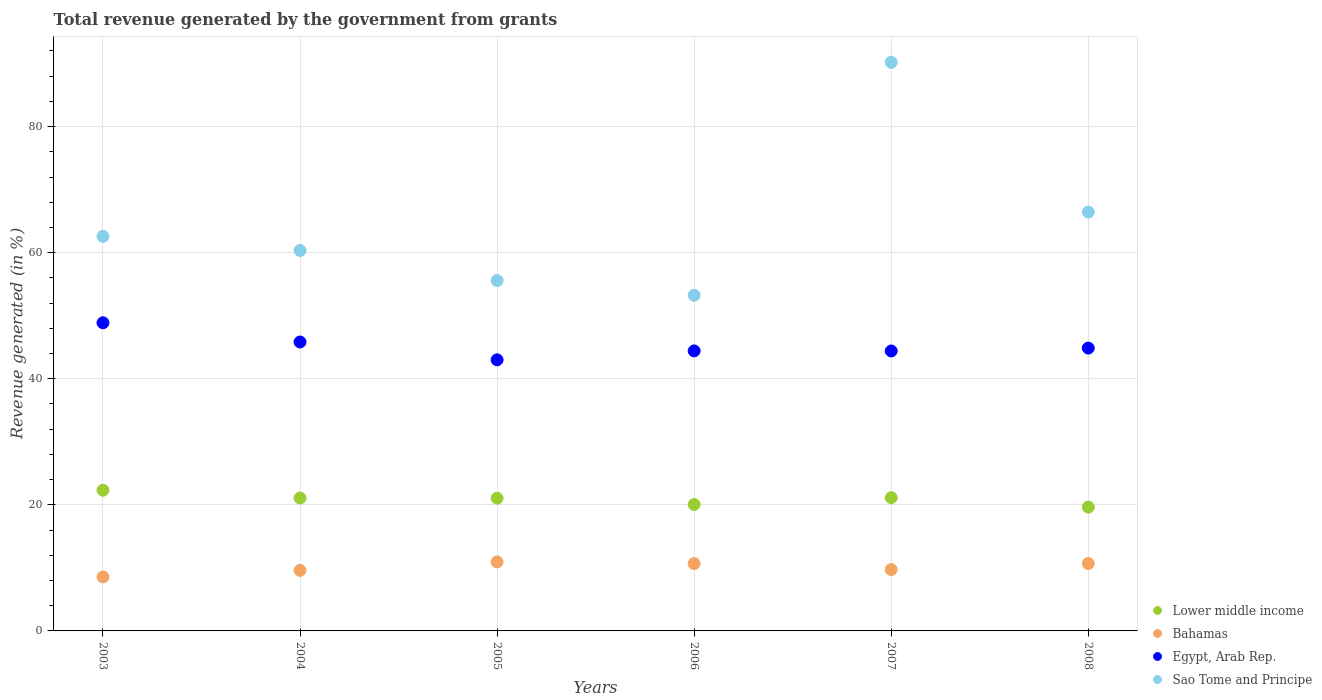What is the total revenue generated in Bahamas in 2005?
Your answer should be compact. 10.95. Across all years, what is the maximum total revenue generated in Sao Tome and Principe?
Provide a short and direct response. 90.2. Across all years, what is the minimum total revenue generated in Egypt, Arab Rep.?
Keep it short and to the point. 43.01. What is the total total revenue generated in Bahamas in the graph?
Offer a terse response. 60.23. What is the difference between the total revenue generated in Bahamas in 2007 and that in 2008?
Your answer should be compact. -0.97. What is the difference between the total revenue generated in Egypt, Arab Rep. in 2005 and the total revenue generated in Sao Tome and Principe in 2007?
Make the answer very short. -47.2. What is the average total revenue generated in Lower middle income per year?
Offer a terse response. 20.88. In the year 2006, what is the difference between the total revenue generated in Egypt, Arab Rep. and total revenue generated in Lower middle income?
Ensure brevity in your answer.  24.38. What is the ratio of the total revenue generated in Egypt, Arab Rep. in 2006 to that in 2007?
Keep it short and to the point. 1. Is the total revenue generated in Sao Tome and Principe in 2005 less than that in 2007?
Your answer should be compact. Yes. Is the difference between the total revenue generated in Egypt, Arab Rep. in 2003 and 2004 greater than the difference between the total revenue generated in Lower middle income in 2003 and 2004?
Your answer should be very brief. Yes. What is the difference between the highest and the second highest total revenue generated in Sao Tome and Principe?
Ensure brevity in your answer.  23.75. What is the difference between the highest and the lowest total revenue generated in Sao Tome and Principe?
Offer a very short reply. 36.96. In how many years, is the total revenue generated in Sao Tome and Principe greater than the average total revenue generated in Sao Tome and Principe taken over all years?
Your response must be concise. 2. Is the sum of the total revenue generated in Lower middle income in 2004 and 2006 greater than the maximum total revenue generated in Egypt, Arab Rep. across all years?
Give a very brief answer. No. Is it the case that in every year, the sum of the total revenue generated in Sao Tome and Principe and total revenue generated in Lower middle income  is greater than the sum of total revenue generated in Egypt, Arab Rep. and total revenue generated in Bahamas?
Offer a terse response. Yes. Is it the case that in every year, the sum of the total revenue generated in Egypt, Arab Rep. and total revenue generated in Lower middle income  is greater than the total revenue generated in Bahamas?
Your answer should be compact. Yes. Does the total revenue generated in Sao Tome and Principe monotonically increase over the years?
Your answer should be very brief. No. Is the total revenue generated in Lower middle income strictly greater than the total revenue generated in Egypt, Arab Rep. over the years?
Keep it short and to the point. No. Are the values on the major ticks of Y-axis written in scientific E-notation?
Your answer should be compact. No. Does the graph contain any zero values?
Keep it short and to the point. No. Does the graph contain grids?
Keep it short and to the point. Yes. How are the legend labels stacked?
Provide a short and direct response. Vertical. What is the title of the graph?
Make the answer very short. Total revenue generated by the government from grants. Does "Panama" appear as one of the legend labels in the graph?
Provide a short and direct response. No. What is the label or title of the Y-axis?
Offer a very short reply. Revenue generated (in %). What is the Revenue generated (in %) of Lower middle income in 2003?
Provide a short and direct response. 22.32. What is the Revenue generated (in %) of Bahamas in 2003?
Your response must be concise. 8.57. What is the Revenue generated (in %) of Egypt, Arab Rep. in 2003?
Offer a terse response. 48.88. What is the Revenue generated (in %) of Sao Tome and Principe in 2003?
Ensure brevity in your answer.  62.58. What is the Revenue generated (in %) in Lower middle income in 2004?
Ensure brevity in your answer.  21.08. What is the Revenue generated (in %) in Bahamas in 2004?
Your answer should be compact. 9.6. What is the Revenue generated (in %) of Egypt, Arab Rep. in 2004?
Keep it short and to the point. 45.83. What is the Revenue generated (in %) in Sao Tome and Principe in 2004?
Ensure brevity in your answer.  60.35. What is the Revenue generated (in %) in Lower middle income in 2005?
Keep it short and to the point. 21.06. What is the Revenue generated (in %) in Bahamas in 2005?
Offer a very short reply. 10.95. What is the Revenue generated (in %) in Egypt, Arab Rep. in 2005?
Make the answer very short. 43.01. What is the Revenue generated (in %) in Sao Tome and Principe in 2005?
Offer a very short reply. 55.58. What is the Revenue generated (in %) of Lower middle income in 2006?
Ensure brevity in your answer.  20.05. What is the Revenue generated (in %) in Bahamas in 2006?
Provide a short and direct response. 10.69. What is the Revenue generated (in %) of Egypt, Arab Rep. in 2006?
Ensure brevity in your answer.  44.42. What is the Revenue generated (in %) of Sao Tome and Principe in 2006?
Provide a short and direct response. 53.24. What is the Revenue generated (in %) in Lower middle income in 2007?
Provide a succinct answer. 21.14. What is the Revenue generated (in %) in Bahamas in 2007?
Offer a terse response. 9.73. What is the Revenue generated (in %) of Egypt, Arab Rep. in 2007?
Make the answer very short. 44.41. What is the Revenue generated (in %) of Sao Tome and Principe in 2007?
Give a very brief answer. 90.2. What is the Revenue generated (in %) of Lower middle income in 2008?
Give a very brief answer. 19.64. What is the Revenue generated (in %) in Bahamas in 2008?
Offer a terse response. 10.7. What is the Revenue generated (in %) in Egypt, Arab Rep. in 2008?
Give a very brief answer. 44.87. What is the Revenue generated (in %) of Sao Tome and Principe in 2008?
Give a very brief answer. 66.45. Across all years, what is the maximum Revenue generated (in %) of Lower middle income?
Ensure brevity in your answer.  22.32. Across all years, what is the maximum Revenue generated (in %) in Bahamas?
Provide a short and direct response. 10.95. Across all years, what is the maximum Revenue generated (in %) of Egypt, Arab Rep.?
Provide a succinct answer. 48.88. Across all years, what is the maximum Revenue generated (in %) of Sao Tome and Principe?
Make the answer very short. 90.2. Across all years, what is the minimum Revenue generated (in %) in Lower middle income?
Keep it short and to the point. 19.64. Across all years, what is the minimum Revenue generated (in %) in Bahamas?
Your answer should be compact. 8.57. Across all years, what is the minimum Revenue generated (in %) in Egypt, Arab Rep.?
Offer a very short reply. 43.01. Across all years, what is the minimum Revenue generated (in %) in Sao Tome and Principe?
Keep it short and to the point. 53.24. What is the total Revenue generated (in %) of Lower middle income in the graph?
Your answer should be compact. 125.28. What is the total Revenue generated (in %) of Bahamas in the graph?
Provide a short and direct response. 60.23. What is the total Revenue generated (in %) in Egypt, Arab Rep. in the graph?
Your answer should be very brief. 271.42. What is the total Revenue generated (in %) of Sao Tome and Principe in the graph?
Your response must be concise. 388.4. What is the difference between the Revenue generated (in %) in Lower middle income in 2003 and that in 2004?
Ensure brevity in your answer.  1.24. What is the difference between the Revenue generated (in %) in Bahamas in 2003 and that in 2004?
Provide a short and direct response. -1.04. What is the difference between the Revenue generated (in %) in Egypt, Arab Rep. in 2003 and that in 2004?
Give a very brief answer. 3.05. What is the difference between the Revenue generated (in %) in Sao Tome and Principe in 2003 and that in 2004?
Offer a terse response. 2.24. What is the difference between the Revenue generated (in %) in Lower middle income in 2003 and that in 2005?
Provide a short and direct response. 1.26. What is the difference between the Revenue generated (in %) of Bahamas in 2003 and that in 2005?
Your answer should be compact. -2.38. What is the difference between the Revenue generated (in %) in Egypt, Arab Rep. in 2003 and that in 2005?
Offer a very short reply. 5.88. What is the difference between the Revenue generated (in %) of Sao Tome and Principe in 2003 and that in 2005?
Your answer should be compact. 7. What is the difference between the Revenue generated (in %) in Lower middle income in 2003 and that in 2006?
Offer a very short reply. 2.27. What is the difference between the Revenue generated (in %) of Bahamas in 2003 and that in 2006?
Give a very brief answer. -2.12. What is the difference between the Revenue generated (in %) in Egypt, Arab Rep. in 2003 and that in 2006?
Provide a short and direct response. 4.46. What is the difference between the Revenue generated (in %) in Sao Tome and Principe in 2003 and that in 2006?
Keep it short and to the point. 9.35. What is the difference between the Revenue generated (in %) of Lower middle income in 2003 and that in 2007?
Keep it short and to the point. 1.18. What is the difference between the Revenue generated (in %) of Bahamas in 2003 and that in 2007?
Provide a succinct answer. -1.16. What is the difference between the Revenue generated (in %) in Egypt, Arab Rep. in 2003 and that in 2007?
Make the answer very short. 4.47. What is the difference between the Revenue generated (in %) in Sao Tome and Principe in 2003 and that in 2007?
Provide a succinct answer. -27.62. What is the difference between the Revenue generated (in %) of Lower middle income in 2003 and that in 2008?
Your answer should be very brief. 2.68. What is the difference between the Revenue generated (in %) of Bahamas in 2003 and that in 2008?
Offer a terse response. -2.13. What is the difference between the Revenue generated (in %) in Egypt, Arab Rep. in 2003 and that in 2008?
Your answer should be compact. 4.02. What is the difference between the Revenue generated (in %) of Sao Tome and Principe in 2003 and that in 2008?
Offer a very short reply. -3.86. What is the difference between the Revenue generated (in %) in Lower middle income in 2004 and that in 2005?
Your answer should be very brief. 0.02. What is the difference between the Revenue generated (in %) of Bahamas in 2004 and that in 2005?
Offer a very short reply. -1.35. What is the difference between the Revenue generated (in %) in Egypt, Arab Rep. in 2004 and that in 2005?
Your answer should be very brief. 2.83. What is the difference between the Revenue generated (in %) in Sao Tome and Principe in 2004 and that in 2005?
Provide a short and direct response. 4.76. What is the difference between the Revenue generated (in %) of Lower middle income in 2004 and that in 2006?
Your response must be concise. 1.03. What is the difference between the Revenue generated (in %) in Bahamas in 2004 and that in 2006?
Your answer should be compact. -1.08. What is the difference between the Revenue generated (in %) of Egypt, Arab Rep. in 2004 and that in 2006?
Offer a very short reply. 1.41. What is the difference between the Revenue generated (in %) in Sao Tome and Principe in 2004 and that in 2006?
Offer a very short reply. 7.11. What is the difference between the Revenue generated (in %) in Lower middle income in 2004 and that in 2007?
Offer a very short reply. -0.06. What is the difference between the Revenue generated (in %) in Bahamas in 2004 and that in 2007?
Your answer should be very brief. -0.13. What is the difference between the Revenue generated (in %) in Egypt, Arab Rep. in 2004 and that in 2007?
Offer a very short reply. 1.43. What is the difference between the Revenue generated (in %) of Sao Tome and Principe in 2004 and that in 2007?
Give a very brief answer. -29.85. What is the difference between the Revenue generated (in %) in Lower middle income in 2004 and that in 2008?
Keep it short and to the point. 1.44. What is the difference between the Revenue generated (in %) in Bahamas in 2004 and that in 2008?
Offer a terse response. -1.09. What is the difference between the Revenue generated (in %) in Egypt, Arab Rep. in 2004 and that in 2008?
Offer a very short reply. 0.97. What is the difference between the Revenue generated (in %) of Sao Tome and Principe in 2004 and that in 2008?
Provide a succinct answer. -6.1. What is the difference between the Revenue generated (in %) in Lower middle income in 2005 and that in 2006?
Provide a short and direct response. 1.01. What is the difference between the Revenue generated (in %) in Bahamas in 2005 and that in 2006?
Your answer should be very brief. 0.26. What is the difference between the Revenue generated (in %) of Egypt, Arab Rep. in 2005 and that in 2006?
Provide a short and direct response. -1.42. What is the difference between the Revenue generated (in %) in Sao Tome and Principe in 2005 and that in 2006?
Offer a very short reply. 2.35. What is the difference between the Revenue generated (in %) of Lower middle income in 2005 and that in 2007?
Your answer should be very brief. -0.08. What is the difference between the Revenue generated (in %) in Bahamas in 2005 and that in 2007?
Ensure brevity in your answer.  1.22. What is the difference between the Revenue generated (in %) of Egypt, Arab Rep. in 2005 and that in 2007?
Offer a terse response. -1.4. What is the difference between the Revenue generated (in %) in Sao Tome and Principe in 2005 and that in 2007?
Make the answer very short. -34.62. What is the difference between the Revenue generated (in %) of Lower middle income in 2005 and that in 2008?
Your answer should be compact. 1.42. What is the difference between the Revenue generated (in %) in Bahamas in 2005 and that in 2008?
Give a very brief answer. 0.25. What is the difference between the Revenue generated (in %) of Egypt, Arab Rep. in 2005 and that in 2008?
Ensure brevity in your answer.  -1.86. What is the difference between the Revenue generated (in %) of Sao Tome and Principe in 2005 and that in 2008?
Make the answer very short. -10.86. What is the difference between the Revenue generated (in %) in Lower middle income in 2006 and that in 2007?
Provide a short and direct response. -1.09. What is the difference between the Revenue generated (in %) in Bahamas in 2006 and that in 2007?
Offer a terse response. 0.96. What is the difference between the Revenue generated (in %) in Egypt, Arab Rep. in 2006 and that in 2007?
Your answer should be very brief. 0.01. What is the difference between the Revenue generated (in %) of Sao Tome and Principe in 2006 and that in 2007?
Give a very brief answer. -36.96. What is the difference between the Revenue generated (in %) in Lower middle income in 2006 and that in 2008?
Give a very brief answer. 0.4. What is the difference between the Revenue generated (in %) of Bahamas in 2006 and that in 2008?
Offer a very short reply. -0.01. What is the difference between the Revenue generated (in %) of Egypt, Arab Rep. in 2006 and that in 2008?
Keep it short and to the point. -0.44. What is the difference between the Revenue generated (in %) of Sao Tome and Principe in 2006 and that in 2008?
Your answer should be very brief. -13.21. What is the difference between the Revenue generated (in %) of Lower middle income in 2007 and that in 2008?
Offer a very short reply. 1.5. What is the difference between the Revenue generated (in %) in Bahamas in 2007 and that in 2008?
Provide a succinct answer. -0.97. What is the difference between the Revenue generated (in %) in Egypt, Arab Rep. in 2007 and that in 2008?
Your answer should be very brief. -0.46. What is the difference between the Revenue generated (in %) in Sao Tome and Principe in 2007 and that in 2008?
Provide a short and direct response. 23.75. What is the difference between the Revenue generated (in %) of Lower middle income in 2003 and the Revenue generated (in %) of Bahamas in 2004?
Your answer should be compact. 12.72. What is the difference between the Revenue generated (in %) of Lower middle income in 2003 and the Revenue generated (in %) of Egypt, Arab Rep. in 2004?
Provide a succinct answer. -23.51. What is the difference between the Revenue generated (in %) in Lower middle income in 2003 and the Revenue generated (in %) in Sao Tome and Principe in 2004?
Provide a succinct answer. -38.03. What is the difference between the Revenue generated (in %) of Bahamas in 2003 and the Revenue generated (in %) of Egypt, Arab Rep. in 2004?
Ensure brevity in your answer.  -37.27. What is the difference between the Revenue generated (in %) of Bahamas in 2003 and the Revenue generated (in %) of Sao Tome and Principe in 2004?
Keep it short and to the point. -51.78. What is the difference between the Revenue generated (in %) of Egypt, Arab Rep. in 2003 and the Revenue generated (in %) of Sao Tome and Principe in 2004?
Offer a terse response. -11.46. What is the difference between the Revenue generated (in %) in Lower middle income in 2003 and the Revenue generated (in %) in Bahamas in 2005?
Your answer should be very brief. 11.37. What is the difference between the Revenue generated (in %) in Lower middle income in 2003 and the Revenue generated (in %) in Egypt, Arab Rep. in 2005?
Your answer should be very brief. -20.69. What is the difference between the Revenue generated (in %) of Lower middle income in 2003 and the Revenue generated (in %) of Sao Tome and Principe in 2005?
Ensure brevity in your answer.  -33.26. What is the difference between the Revenue generated (in %) of Bahamas in 2003 and the Revenue generated (in %) of Egypt, Arab Rep. in 2005?
Provide a succinct answer. -34.44. What is the difference between the Revenue generated (in %) in Bahamas in 2003 and the Revenue generated (in %) in Sao Tome and Principe in 2005?
Provide a succinct answer. -47.02. What is the difference between the Revenue generated (in %) in Egypt, Arab Rep. in 2003 and the Revenue generated (in %) in Sao Tome and Principe in 2005?
Give a very brief answer. -6.7. What is the difference between the Revenue generated (in %) of Lower middle income in 2003 and the Revenue generated (in %) of Bahamas in 2006?
Offer a terse response. 11.63. What is the difference between the Revenue generated (in %) in Lower middle income in 2003 and the Revenue generated (in %) in Egypt, Arab Rep. in 2006?
Your answer should be compact. -22.1. What is the difference between the Revenue generated (in %) of Lower middle income in 2003 and the Revenue generated (in %) of Sao Tome and Principe in 2006?
Your response must be concise. -30.92. What is the difference between the Revenue generated (in %) of Bahamas in 2003 and the Revenue generated (in %) of Egypt, Arab Rep. in 2006?
Provide a short and direct response. -35.85. What is the difference between the Revenue generated (in %) of Bahamas in 2003 and the Revenue generated (in %) of Sao Tome and Principe in 2006?
Your response must be concise. -44.67. What is the difference between the Revenue generated (in %) of Egypt, Arab Rep. in 2003 and the Revenue generated (in %) of Sao Tome and Principe in 2006?
Provide a succinct answer. -4.36. What is the difference between the Revenue generated (in %) in Lower middle income in 2003 and the Revenue generated (in %) in Bahamas in 2007?
Ensure brevity in your answer.  12.59. What is the difference between the Revenue generated (in %) in Lower middle income in 2003 and the Revenue generated (in %) in Egypt, Arab Rep. in 2007?
Your answer should be compact. -22.09. What is the difference between the Revenue generated (in %) of Lower middle income in 2003 and the Revenue generated (in %) of Sao Tome and Principe in 2007?
Keep it short and to the point. -67.88. What is the difference between the Revenue generated (in %) of Bahamas in 2003 and the Revenue generated (in %) of Egypt, Arab Rep. in 2007?
Give a very brief answer. -35.84. What is the difference between the Revenue generated (in %) of Bahamas in 2003 and the Revenue generated (in %) of Sao Tome and Principe in 2007?
Your answer should be very brief. -81.63. What is the difference between the Revenue generated (in %) in Egypt, Arab Rep. in 2003 and the Revenue generated (in %) in Sao Tome and Principe in 2007?
Offer a very short reply. -41.32. What is the difference between the Revenue generated (in %) of Lower middle income in 2003 and the Revenue generated (in %) of Bahamas in 2008?
Your answer should be very brief. 11.62. What is the difference between the Revenue generated (in %) in Lower middle income in 2003 and the Revenue generated (in %) in Egypt, Arab Rep. in 2008?
Make the answer very short. -22.55. What is the difference between the Revenue generated (in %) in Lower middle income in 2003 and the Revenue generated (in %) in Sao Tome and Principe in 2008?
Keep it short and to the point. -44.13. What is the difference between the Revenue generated (in %) of Bahamas in 2003 and the Revenue generated (in %) of Egypt, Arab Rep. in 2008?
Your answer should be compact. -36.3. What is the difference between the Revenue generated (in %) of Bahamas in 2003 and the Revenue generated (in %) of Sao Tome and Principe in 2008?
Make the answer very short. -57.88. What is the difference between the Revenue generated (in %) of Egypt, Arab Rep. in 2003 and the Revenue generated (in %) of Sao Tome and Principe in 2008?
Provide a short and direct response. -17.56. What is the difference between the Revenue generated (in %) in Lower middle income in 2004 and the Revenue generated (in %) in Bahamas in 2005?
Your answer should be very brief. 10.13. What is the difference between the Revenue generated (in %) in Lower middle income in 2004 and the Revenue generated (in %) in Egypt, Arab Rep. in 2005?
Provide a short and direct response. -21.93. What is the difference between the Revenue generated (in %) of Lower middle income in 2004 and the Revenue generated (in %) of Sao Tome and Principe in 2005?
Your answer should be compact. -34.51. What is the difference between the Revenue generated (in %) in Bahamas in 2004 and the Revenue generated (in %) in Egypt, Arab Rep. in 2005?
Keep it short and to the point. -33.4. What is the difference between the Revenue generated (in %) in Bahamas in 2004 and the Revenue generated (in %) in Sao Tome and Principe in 2005?
Keep it short and to the point. -45.98. What is the difference between the Revenue generated (in %) in Egypt, Arab Rep. in 2004 and the Revenue generated (in %) in Sao Tome and Principe in 2005?
Your answer should be compact. -9.75. What is the difference between the Revenue generated (in %) in Lower middle income in 2004 and the Revenue generated (in %) in Bahamas in 2006?
Offer a terse response. 10.39. What is the difference between the Revenue generated (in %) in Lower middle income in 2004 and the Revenue generated (in %) in Egypt, Arab Rep. in 2006?
Keep it short and to the point. -23.34. What is the difference between the Revenue generated (in %) in Lower middle income in 2004 and the Revenue generated (in %) in Sao Tome and Principe in 2006?
Your response must be concise. -32.16. What is the difference between the Revenue generated (in %) in Bahamas in 2004 and the Revenue generated (in %) in Egypt, Arab Rep. in 2006?
Give a very brief answer. -34.82. What is the difference between the Revenue generated (in %) in Bahamas in 2004 and the Revenue generated (in %) in Sao Tome and Principe in 2006?
Give a very brief answer. -43.63. What is the difference between the Revenue generated (in %) in Egypt, Arab Rep. in 2004 and the Revenue generated (in %) in Sao Tome and Principe in 2006?
Keep it short and to the point. -7.4. What is the difference between the Revenue generated (in %) in Lower middle income in 2004 and the Revenue generated (in %) in Bahamas in 2007?
Offer a very short reply. 11.35. What is the difference between the Revenue generated (in %) of Lower middle income in 2004 and the Revenue generated (in %) of Egypt, Arab Rep. in 2007?
Your response must be concise. -23.33. What is the difference between the Revenue generated (in %) of Lower middle income in 2004 and the Revenue generated (in %) of Sao Tome and Principe in 2007?
Your response must be concise. -69.12. What is the difference between the Revenue generated (in %) in Bahamas in 2004 and the Revenue generated (in %) in Egypt, Arab Rep. in 2007?
Your answer should be compact. -34.81. What is the difference between the Revenue generated (in %) of Bahamas in 2004 and the Revenue generated (in %) of Sao Tome and Principe in 2007?
Your answer should be compact. -80.6. What is the difference between the Revenue generated (in %) of Egypt, Arab Rep. in 2004 and the Revenue generated (in %) of Sao Tome and Principe in 2007?
Make the answer very short. -44.37. What is the difference between the Revenue generated (in %) in Lower middle income in 2004 and the Revenue generated (in %) in Bahamas in 2008?
Provide a short and direct response. 10.38. What is the difference between the Revenue generated (in %) in Lower middle income in 2004 and the Revenue generated (in %) in Egypt, Arab Rep. in 2008?
Make the answer very short. -23.79. What is the difference between the Revenue generated (in %) of Lower middle income in 2004 and the Revenue generated (in %) of Sao Tome and Principe in 2008?
Your response must be concise. -45.37. What is the difference between the Revenue generated (in %) of Bahamas in 2004 and the Revenue generated (in %) of Egypt, Arab Rep. in 2008?
Make the answer very short. -35.26. What is the difference between the Revenue generated (in %) of Bahamas in 2004 and the Revenue generated (in %) of Sao Tome and Principe in 2008?
Offer a terse response. -56.84. What is the difference between the Revenue generated (in %) of Egypt, Arab Rep. in 2004 and the Revenue generated (in %) of Sao Tome and Principe in 2008?
Make the answer very short. -20.61. What is the difference between the Revenue generated (in %) in Lower middle income in 2005 and the Revenue generated (in %) in Bahamas in 2006?
Provide a succinct answer. 10.37. What is the difference between the Revenue generated (in %) in Lower middle income in 2005 and the Revenue generated (in %) in Egypt, Arab Rep. in 2006?
Give a very brief answer. -23.36. What is the difference between the Revenue generated (in %) of Lower middle income in 2005 and the Revenue generated (in %) of Sao Tome and Principe in 2006?
Make the answer very short. -32.18. What is the difference between the Revenue generated (in %) in Bahamas in 2005 and the Revenue generated (in %) in Egypt, Arab Rep. in 2006?
Your answer should be very brief. -33.47. What is the difference between the Revenue generated (in %) in Bahamas in 2005 and the Revenue generated (in %) in Sao Tome and Principe in 2006?
Give a very brief answer. -42.29. What is the difference between the Revenue generated (in %) in Egypt, Arab Rep. in 2005 and the Revenue generated (in %) in Sao Tome and Principe in 2006?
Make the answer very short. -10.23. What is the difference between the Revenue generated (in %) in Lower middle income in 2005 and the Revenue generated (in %) in Bahamas in 2007?
Your response must be concise. 11.33. What is the difference between the Revenue generated (in %) in Lower middle income in 2005 and the Revenue generated (in %) in Egypt, Arab Rep. in 2007?
Your answer should be compact. -23.35. What is the difference between the Revenue generated (in %) in Lower middle income in 2005 and the Revenue generated (in %) in Sao Tome and Principe in 2007?
Offer a terse response. -69.14. What is the difference between the Revenue generated (in %) of Bahamas in 2005 and the Revenue generated (in %) of Egypt, Arab Rep. in 2007?
Ensure brevity in your answer.  -33.46. What is the difference between the Revenue generated (in %) of Bahamas in 2005 and the Revenue generated (in %) of Sao Tome and Principe in 2007?
Offer a very short reply. -79.25. What is the difference between the Revenue generated (in %) of Egypt, Arab Rep. in 2005 and the Revenue generated (in %) of Sao Tome and Principe in 2007?
Make the answer very short. -47.2. What is the difference between the Revenue generated (in %) of Lower middle income in 2005 and the Revenue generated (in %) of Bahamas in 2008?
Offer a very short reply. 10.36. What is the difference between the Revenue generated (in %) in Lower middle income in 2005 and the Revenue generated (in %) in Egypt, Arab Rep. in 2008?
Provide a short and direct response. -23.81. What is the difference between the Revenue generated (in %) in Lower middle income in 2005 and the Revenue generated (in %) in Sao Tome and Principe in 2008?
Provide a short and direct response. -45.39. What is the difference between the Revenue generated (in %) in Bahamas in 2005 and the Revenue generated (in %) in Egypt, Arab Rep. in 2008?
Offer a terse response. -33.91. What is the difference between the Revenue generated (in %) in Bahamas in 2005 and the Revenue generated (in %) in Sao Tome and Principe in 2008?
Provide a short and direct response. -55.5. What is the difference between the Revenue generated (in %) of Egypt, Arab Rep. in 2005 and the Revenue generated (in %) of Sao Tome and Principe in 2008?
Your response must be concise. -23.44. What is the difference between the Revenue generated (in %) of Lower middle income in 2006 and the Revenue generated (in %) of Bahamas in 2007?
Your response must be concise. 10.32. What is the difference between the Revenue generated (in %) in Lower middle income in 2006 and the Revenue generated (in %) in Egypt, Arab Rep. in 2007?
Offer a very short reply. -24.36. What is the difference between the Revenue generated (in %) in Lower middle income in 2006 and the Revenue generated (in %) in Sao Tome and Principe in 2007?
Your answer should be very brief. -70.15. What is the difference between the Revenue generated (in %) of Bahamas in 2006 and the Revenue generated (in %) of Egypt, Arab Rep. in 2007?
Ensure brevity in your answer.  -33.72. What is the difference between the Revenue generated (in %) in Bahamas in 2006 and the Revenue generated (in %) in Sao Tome and Principe in 2007?
Provide a short and direct response. -79.51. What is the difference between the Revenue generated (in %) in Egypt, Arab Rep. in 2006 and the Revenue generated (in %) in Sao Tome and Principe in 2007?
Your response must be concise. -45.78. What is the difference between the Revenue generated (in %) of Lower middle income in 2006 and the Revenue generated (in %) of Bahamas in 2008?
Your answer should be compact. 9.35. What is the difference between the Revenue generated (in %) in Lower middle income in 2006 and the Revenue generated (in %) in Egypt, Arab Rep. in 2008?
Offer a very short reply. -24.82. What is the difference between the Revenue generated (in %) of Lower middle income in 2006 and the Revenue generated (in %) of Sao Tome and Principe in 2008?
Make the answer very short. -46.4. What is the difference between the Revenue generated (in %) in Bahamas in 2006 and the Revenue generated (in %) in Egypt, Arab Rep. in 2008?
Give a very brief answer. -34.18. What is the difference between the Revenue generated (in %) in Bahamas in 2006 and the Revenue generated (in %) in Sao Tome and Principe in 2008?
Provide a succinct answer. -55.76. What is the difference between the Revenue generated (in %) of Egypt, Arab Rep. in 2006 and the Revenue generated (in %) of Sao Tome and Principe in 2008?
Your answer should be compact. -22.02. What is the difference between the Revenue generated (in %) of Lower middle income in 2007 and the Revenue generated (in %) of Bahamas in 2008?
Keep it short and to the point. 10.44. What is the difference between the Revenue generated (in %) of Lower middle income in 2007 and the Revenue generated (in %) of Egypt, Arab Rep. in 2008?
Offer a very short reply. -23.73. What is the difference between the Revenue generated (in %) in Lower middle income in 2007 and the Revenue generated (in %) in Sao Tome and Principe in 2008?
Your response must be concise. -45.31. What is the difference between the Revenue generated (in %) of Bahamas in 2007 and the Revenue generated (in %) of Egypt, Arab Rep. in 2008?
Provide a succinct answer. -35.14. What is the difference between the Revenue generated (in %) in Bahamas in 2007 and the Revenue generated (in %) in Sao Tome and Principe in 2008?
Keep it short and to the point. -56.72. What is the difference between the Revenue generated (in %) of Egypt, Arab Rep. in 2007 and the Revenue generated (in %) of Sao Tome and Principe in 2008?
Offer a terse response. -22.04. What is the average Revenue generated (in %) of Lower middle income per year?
Your answer should be compact. 20.88. What is the average Revenue generated (in %) of Bahamas per year?
Offer a very short reply. 10.04. What is the average Revenue generated (in %) of Egypt, Arab Rep. per year?
Keep it short and to the point. 45.24. What is the average Revenue generated (in %) of Sao Tome and Principe per year?
Provide a succinct answer. 64.73. In the year 2003, what is the difference between the Revenue generated (in %) in Lower middle income and Revenue generated (in %) in Bahamas?
Ensure brevity in your answer.  13.75. In the year 2003, what is the difference between the Revenue generated (in %) in Lower middle income and Revenue generated (in %) in Egypt, Arab Rep.?
Offer a very short reply. -26.56. In the year 2003, what is the difference between the Revenue generated (in %) in Lower middle income and Revenue generated (in %) in Sao Tome and Principe?
Ensure brevity in your answer.  -40.27. In the year 2003, what is the difference between the Revenue generated (in %) of Bahamas and Revenue generated (in %) of Egypt, Arab Rep.?
Your answer should be very brief. -40.31. In the year 2003, what is the difference between the Revenue generated (in %) of Bahamas and Revenue generated (in %) of Sao Tome and Principe?
Your answer should be compact. -54.02. In the year 2003, what is the difference between the Revenue generated (in %) in Egypt, Arab Rep. and Revenue generated (in %) in Sao Tome and Principe?
Your response must be concise. -13.7. In the year 2004, what is the difference between the Revenue generated (in %) of Lower middle income and Revenue generated (in %) of Bahamas?
Provide a succinct answer. 11.47. In the year 2004, what is the difference between the Revenue generated (in %) of Lower middle income and Revenue generated (in %) of Egypt, Arab Rep.?
Offer a very short reply. -24.76. In the year 2004, what is the difference between the Revenue generated (in %) of Lower middle income and Revenue generated (in %) of Sao Tome and Principe?
Offer a very short reply. -39.27. In the year 2004, what is the difference between the Revenue generated (in %) in Bahamas and Revenue generated (in %) in Egypt, Arab Rep.?
Keep it short and to the point. -36.23. In the year 2004, what is the difference between the Revenue generated (in %) in Bahamas and Revenue generated (in %) in Sao Tome and Principe?
Your response must be concise. -50.74. In the year 2004, what is the difference between the Revenue generated (in %) in Egypt, Arab Rep. and Revenue generated (in %) in Sao Tome and Principe?
Provide a short and direct response. -14.51. In the year 2005, what is the difference between the Revenue generated (in %) in Lower middle income and Revenue generated (in %) in Bahamas?
Give a very brief answer. 10.11. In the year 2005, what is the difference between the Revenue generated (in %) in Lower middle income and Revenue generated (in %) in Egypt, Arab Rep.?
Offer a very short reply. -21.95. In the year 2005, what is the difference between the Revenue generated (in %) of Lower middle income and Revenue generated (in %) of Sao Tome and Principe?
Offer a very short reply. -34.52. In the year 2005, what is the difference between the Revenue generated (in %) in Bahamas and Revenue generated (in %) in Egypt, Arab Rep.?
Your response must be concise. -32.05. In the year 2005, what is the difference between the Revenue generated (in %) of Bahamas and Revenue generated (in %) of Sao Tome and Principe?
Offer a very short reply. -44.63. In the year 2005, what is the difference between the Revenue generated (in %) of Egypt, Arab Rep. and Revenue generated (in %) of Sao Tome and Principe?
Ensure brevity in your answer.  -12.58. In the year 2006, what is the difference between the Revenue generated (in %) of Lower middle income and Revenue generated (in %) of Bahamas?
Make the answer very short. 9.36. In the year 2006, what is the difference between the Revenue generated (in %) of Lower middle income and Revenue generated (in %) of Egypt, Arab Rep.?
Your answer should be very brief. -24.38. In the year 2006, what is the difference between the Revenue generated (in %) of Lower middle income and Revenue generated (in %) of Sao Tome and Principe?
Provide a succinct answer. -33.19. In the year 2006, what is the difference between the Revenue generated (in %) in Bahamas and Revenue generated (in %) in Egypt, Arab Rep.?
Keep it short and to the point. -33.74. In the year 2006, what is the difference between the Revenue generated (in %) of Bahamas and Revenue generated (in %) of Sao Tome and Principe?
Provide a short and direct response. -42.55. In the year 2006, what is the difference between the Revenue generated (in %) of Egypt, Arab Rep. and Revenue generated (in %) of Sao Tome and Principe?
Make the answer very short. -8.82. In the year 2007, what is the difference between the Revenue generated (in %) in Lower middle income and Revenue generated (in %) in Bahamas?
Keep it short and to the point. 11.41. In the year 2007, what is the difference between the Revenue generated (in %) of Lower middle income and Revenue generated (in %) of Egypt, Arab Rep.?
Give a very brief answer. -23.27. In the year 2007, what is the difference between the Revenue generated (in %) in Lower middle income and Revenue generated (in %) in Sao Tome and Principe?
Your response must be concise. -69.06. In the year 2007, what is the difference between the Revenue generated (in %) of Bahamas and Revenue generated (in %) of Egypt, Arab Rep.?
Provide a short and direct response. -34.68. In the year 2007, what is the difference between the Revenue generated (in %) of Bahamas and Revenue generated (in %) of Sao Tome and Principe?
Provide a succinct answer. -80.47. In the year 2007, what is the difference between the Revenue generated (in %) in Egypt, Arab Rep. and Revenue generated (in %) in Sao Tome and Principe?
Your response must be concise. -45.79. In the year 2008, what is the difference between the Revenue generated (in %) in Lower middle income and Revenue generated (in %) in Bahamas?
Give a very brief answer. 8.95. In the year 2008, what is the difference between the Revenue generated (in %) in Lower middle income and Revenue generated (in %) in Egypt, Arab Rep.?
Your answer should be compact. -25.22. In the year 2008, what is the difference between the Revenue generated (in %) of Lower middle income and Revenue generated (in %) of Sao Tome and Principe?
Offer a terse response. -46.8. In the year 2008, what is the difference between the Revenue generated (in %) in Bahamas and Revenue generated (in %) in Egypt, Arab Rep.?
Provide a succinct answer. -34.17. In the year 2008, what is the difference between the Revenue generated (in %) in Bahamas and Revenue generated (in %) in Sao Tome and Principe?
Your answer should be very brief. -55.75. In the year 2008, what is the difference between the Revenue generated (in %) in Egypt, Arab Rep. and Revenue generated (in %) in Sao Tome and Principe?
Keep it short and to the point. -21.58. What is the ratio of the Revenue generated (in %) of Lower middle income in 2003 to that in 2004?
Ensure brevity in your answer.  1.06. What is the ratio of the Revenue generated (in %) of Bahamas in 2003 to that in 2004?
Your response must be concise. 0.89. What is the ratio of the Revenue generated (in %) in Egypt, Arab Rep. in 2003 to that in 2004?
Ensure brevity in your answer.  1.07. What is the ratio of the Revenue generated (in %) in Sao Tome and Principe in 2003 to that in 2004?
Offer a terse response. 1.04. What is the ratio of the Revenue generated (in %) of Lower middle income in 2003 to that in 2005?
Keep it short and to the point. 1.06. What is the ratio of the Revenue generated (in %) of Bahamas in 2003 to that in 2005?
Your answer should be compact. 0.78. What is the ratio of the Revenue generated (in %) of Egypt, Arab Rep. in 2003 to that in 2005?
Your answer should be compact. 1.14. What is the ratio of the Revenue generated (in %) of Sao Tome and Principe in 2003 to that in 2005?
Keep it short and to the point. 1.13. What is the ratio of the Revenue generated (in %) in Lower middle income in 2003 to that in 2006?
Give a very brief answer. 1.11. What is the ratio of the Revenue generated (in %) of Bahamas in 2003 to that in 2006?
Your response must be concise. 0.8. What is the ratio of the Revenue generated (in %) in Egypt, Arab Rep. in 2003 to that in 2006?
Provide a short and direct response. 1.1. What is the ratio of the Revenue generated (in %) of Sao Tome and Principe in 2003 to that in 2006?
Make the answer very short. 1.18. What is the ratio of the Revenue generated (in %) in Lower middle income in 2003 to that in 2007?
Offer a very short reply. 1.06. What is the ratio of the Revenue generated (in %) of Bahamas in 2003 to that in 2007?
Offer a terse response. 0.88. What is the ratio of the Revenue generated (in %) of Egypt, Arab Rep. in 2003 to that in 2007?
Ensure brevity in your answer.  1.1. What is the ratio of the Revenue generated (in %) in Sao Tome and Principe in 2003 to that in 2007?
Your answer should be compact. 0.69. What is the ratio of the Revenue generated (in %) in Lower middle income in 2003 to that in 2008?
Give a very brief answer. 1.14. What is the ratio of the Revenue generated (in %) in Bahamas in 2003 to that in 2008?
Offer a very short reply. 0.8. What is the ratio of the Revenue generated (in %) in Egypt, Arab Rep. in 2003 to that in 2008?
Your answer should be compact. 1.09. What is the ratio of the Revenue generated (in %) of Sao Tome and Principe in 2003 to that in 2008?
Make the answer very short. 0.94. What is the ratio of the Revenue generated (in %) of Bahamas in 2004 to that in 2005?
Your answer should be very brief. 0.88. What is the ratio of the Revenue generated (in %) of Egypt, Arab Rep. in 2004 to that in 2005?
Ensure brevity in your answer.  1.07. What is the ratio of the Revenue generated (in %) of Sao Tome and Principe in 2004 to that in 2005?
Provide a short and direct response. 1.09. What is the ratio of the Revenue generated (in %) in Lower middle income in 2004 to that in 2006?
Your answer should be compact. 1.05. What is the ratio of the Revenue generated (in %) in Bahamas in 2004 to that in 2006?
Give a very brief answer. 0.9. What is the ratio of the Revenue generated (in %) of Egypt, Arab Rep. in 2004 to that in 2006?
Provide a short and direct response. 1.03. What is the ratio of the Revenue generated (in %) in Sao Tome and Principe in 2004 to that in 2006?
Your answer should be very brief. 1.13. What is the ratio of the Revenue generated (in %) of Lower middle income in 2004 to that in 2007?
Keep it short and to the point. 1. What is the ratio of the Revenue generated (in %) of Bahamas in 2004 to that in 2007?
Keep it short and to the point. 0.99. What is the ratio of the Revenue generated (in %) of Egypt, Arab Rep. in 2004 to that in 2007?
Your response must be concise. 1.03. What is the ratio of the Revenue generated (in %) of Sao Tome and Principe in 2004 to that in 2007?
Give a very brief answer. 0.67. What is the ratio of the Revenue generated (in %) in Lower middle income in 2004 to that in 2008?
Ensure brevity in your answer.  1.07. What is the ratio of the Revenue generated (in %) of Bahamas in 2004 to that in 2008?
Keep it short and to the point. 0.9. What is the ratio of the Revenue generated (in %) of Egypt, Arab Rep. in 2004 to that in 2008?
Offer a terse response. 1.02. What is the ratio of the Revenue generated (in %) in Sao Tome and Principe in 2004 to that in 2008?
Keep it short and to the point. 0.91. What is the ratio of the Revenue generated (in %) of Lower middle income in 2005 to that in 2006?
Provide a short and direct response. 1.05. What is the ratio of the Revenue generated (in %) in Bahamas in 2005 to that in 2006?
Keep it short and to the point. 1.02. What is the ratio of the Revenue generated (in %) in Egypt, Arab Rep. in 2005 to that in 2006?
Make the answer very short. 0.97. What is the ratio of the Revenue generated (in %) of Sao Tome and Principe in 2005 to that in 2006?
Your answer should be very brief. 1.04. What is the ratio of the Revenue generated (in %) in Lower middle income in 2005 to that in 2007?
Keep it short and to the point. 1. What is the ratio of the Revenue generated (in %) in Bahamas in 2005 to that in 2007?
Offer a terse response. 1.13. What is the ratio of the Revenue generated (in %) in Egypt, Arab Rep. in 2005 to that in 2007?
Your response must be concise. 0.97. What is the ratio of the Revenue generated (in %) in Sao Tome and Principe in 2005 to that in 2007?
Provide a succinct answer. 0.62. What is the ratio of the Revenue generated (in %) of Lower middle income in 2005 to that in 2008?
Offer a very short reply. 1.07. What is the ratio of the Revenue generated (in %) in Bahamas in 2005 to that in 2008?
Keep it short and to the point. 1.02. What is the ratio of the Revenue generated (in %) in Egypt, Arab Rep. in 2005 to that in 2008?
Ensure brevity in your answer.  0.96. What is the ratio of the Revenue generated (in %) of Sao Tome and Principe in 2005 to that in 2008?
Your answer should be compact. 0.84. What is the ratio of the Revenue generated (in %) of Lower middle income in 2006 to that in 2007?
Your answer should be very brief. 0.95. What is the ratio of the Revenue generated (in %) of Bahamas in 2006 to that in 2007?
Ensure brevity in your answer.  1.1. What is the ratio of the Revenue generated (in %) of Sao Tome and Principe in 2006 to that in 2007?
Make the answer very short. 0.59. What is the ratio of the Revenue generated (in %) in Lower middle income in 2006 to that in 2008?
Provide a succinct answer. 1.02. What is the ratio of the Revenue generated (in %) of Bahamas in 2006 to that in 2008?
Make the answer very short. 1. What is the ratio of the Revenue generated (in %) of Egypt, Arab Rep. in 2006 to that in 2008?
Provide a short and direct response. 0.99. What is the ratio of the Revenue generated (in %) of Sao Tome and Principe in 2006 to that in 2008?
Offer a very short reply. 0.8. What is the ratio of the Revenue generated (in %) of Lower middle income in 2007 to that in 2008?
Provide a succinct answer. 1.08. What is the ratio of the Revenue generated (in %) of Bahamas in 2007 to that in 2008?
Offer a very short reply. 0.91. What is the ratio of the Revenue generated (in %) of Sao Tome and Principe in 2007 to that in 2008?
Provide a short and direct response. 1.36. What is the difference between the highest and the second highest Revenue generated (in %) of Lower middle income?
Offer a terse response. 1.18. What is the difference between the highest and the second highest Revenue generated (in %) of Bahamas?
Your answer should be very brief. 0.25. What is the difference between the highest and the second highest Revenue generated (in %) of Egypt, Arab Rep.?
Your answer should be very brief. 3.05. What is the difference between the highest and the second highest Revenue generated (in %) in Sao Tome and Principe?
Keep it short and to the point. 23.75. What is the difference between the highest and the lowest Revenue generated (in %) in Lower middle income?
Your answer should be compact. 2.68. What is the difference between the highest and the lowest Revenue generated (in %) in Bahamas?
Offer a terse response. 2.38. What is the difference between the highest and the lowest Revenue generated (in %) of Egypt, Arab Rep.?
Your answer should be very brief. 5.88. What is the difference between the highest and the lowest Revenue generated (in %) of Sao Tome and Principe?
Give a very brief answer. 36.96. 